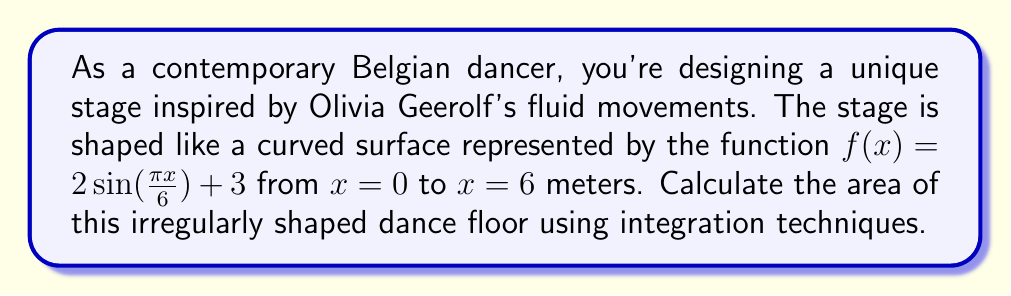Provide a solution to this math problem. To find the area of this irregularly shaped dance floor, we need to use integration. The steps are as follows:

1) The area under a curve is given by the definite integral:

   $$A = \int_a^b f(x) dx$$

2) In this case, $f(x) = 2\sin(\frac{\pi x}{6}) + 3$, $a = 0$, and $b = 6$. So we have:

   $$A = \int_0^6 (2\sin(\frac{\pi x}{6}) + 3) dx$$

3) Let's integrate this step by step:

   $$A = \int_0^6 2\sin(\frac{\pi x}{6}) dx + \int_0^6 3 dx$$

4) For the first integral, we use the substitution $u = \frac{\pi x}{6}$, so $du = \frac{\pi}{6} dx$ or $dx = \frac{6}{\pi} du$:

   $$\int_0^6 2\sin(\frac{\pi x}{6}) dx = \frac{12}{\pi} \int_0^\pi \sin(u) du = -\frac{12}{\pi} \cos(u) \Big|_0^\pi = -\frac{12}{\pi} (\cos(\pi) - \cos(0)) = \frac{24}{\pi}$$

5) The second integral is straightforward:

   $$\int_0^6 3 dx = 3x \Big|_0^6 = 18$$

6) Adding these results:

   $$A = \frac{24}{\pi} + 18 = \frac{24 + 18\pi}{\pi} = \frac{24 + 18\pi}{\pi} \approx 25.64$$

Therefore, the area of the dance floor is $\frac{24 + 18\pi}{\pi}$ square meters.
Answer: $\frac{24 + 18\pi}{\pi}$ square meters 